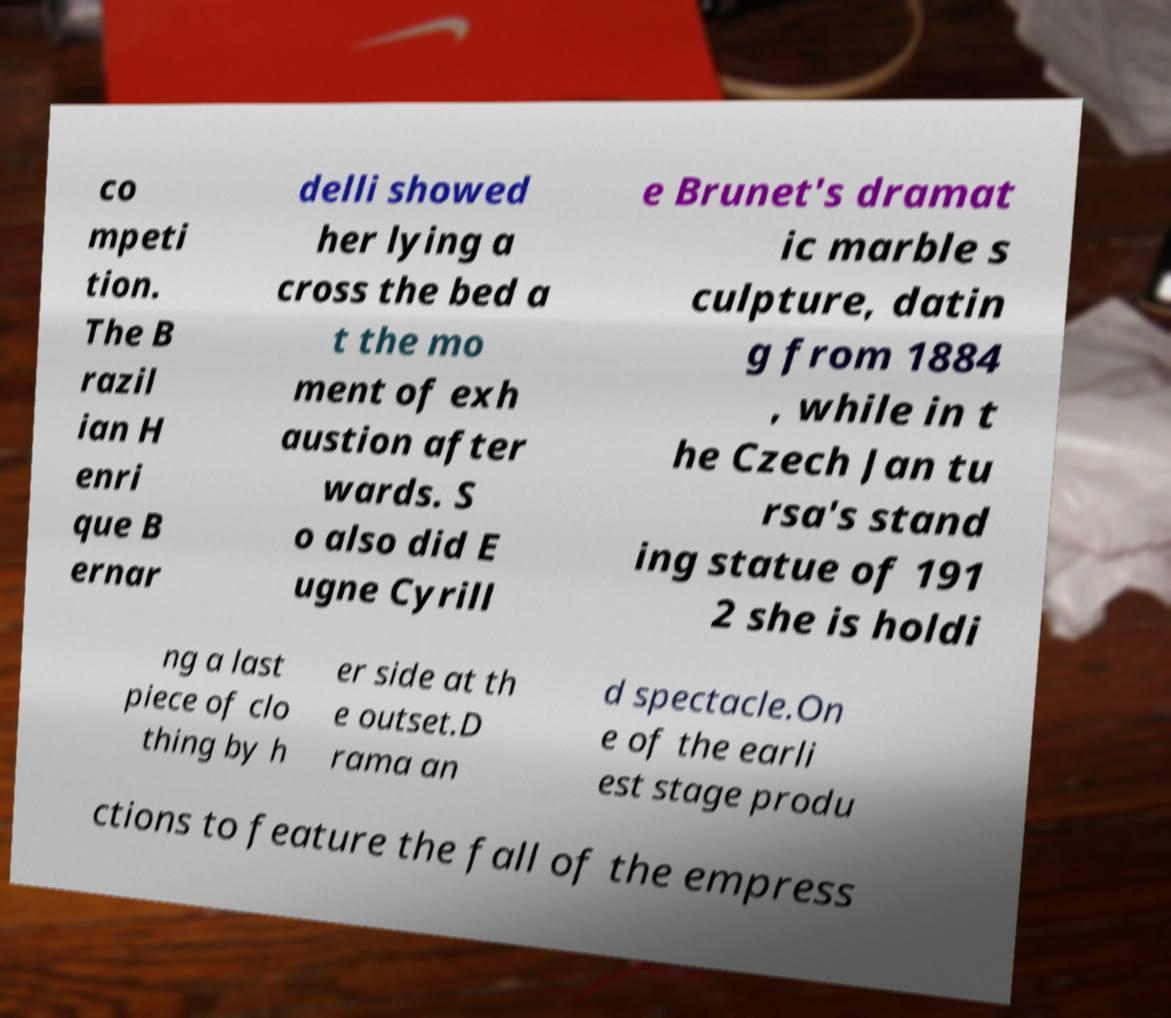What messages or text are displayed in this image? I need them in a readable, typed format. co mpeti tion. The B razil ian H enri que B ernar delli showed her lying a cross the bed a t the mo ment of exh austion after wards. S o also did E ugne Cyrill e Brunet's dramat ic marble s culpture, datin g from 1884 , while in t he Czech Jan tu rsa's stand ing statue of 191 2 she is holdi ng a last piece of clo thing by h er side at th e outset.D rama an d spectacle.On e of the earli est stage produ ctions to feature the fall of the empress 